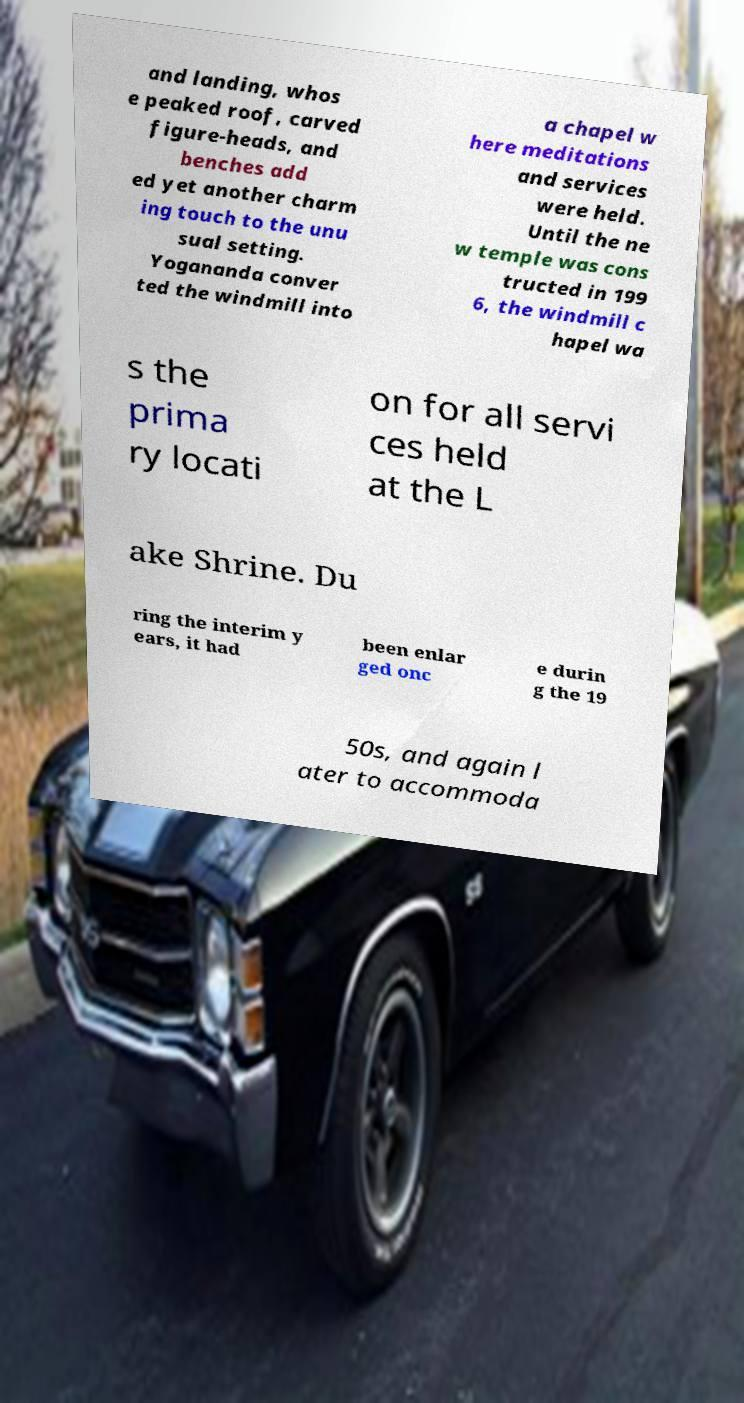Please identify and transcribe the text found in this image. and landing, whos e peaked roof, carved figure-heads, and benches add ed yet another charm ing touch to the unu sual setting. Yogananda conver ted the windmill into a chapel w here meditations and services were held. Until the ne w temple was cons tructed in 199 6, the windmill c hapel wa s the prima ry locati on for all servi ces held at the L ake Shrine. Du ring the interim y ears, it had been enlar ged onc e durin g the 19 50s, and again l ater to accommoda 